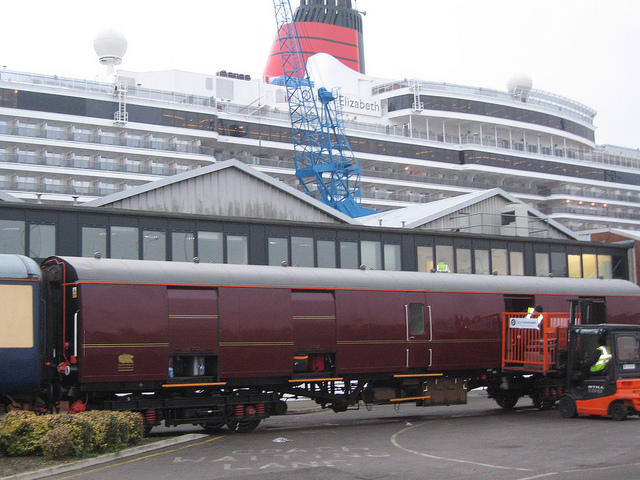<image>Which of these vehicles would float? It is ambiguous which vehicles would float as it could be a boat, ship or none. Which of these vehicles would float? It is ambiguous which of these vehicles would float. It can be both boat and ship. 